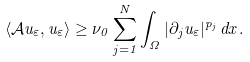<formula> <loc_0><loc_0><loc_500><loc_500>\langle \mathcal { A } u _ { \varepsilon } , u _ { \varepsilon } \rangle \geq \nu _ { 0 } \sum _ { j = 1 } ^ { N } \int _ { \Omega } | \partial _ { j } u _ { \varepsilon } | ^ { p _ { j } } \, d x .</formula> 